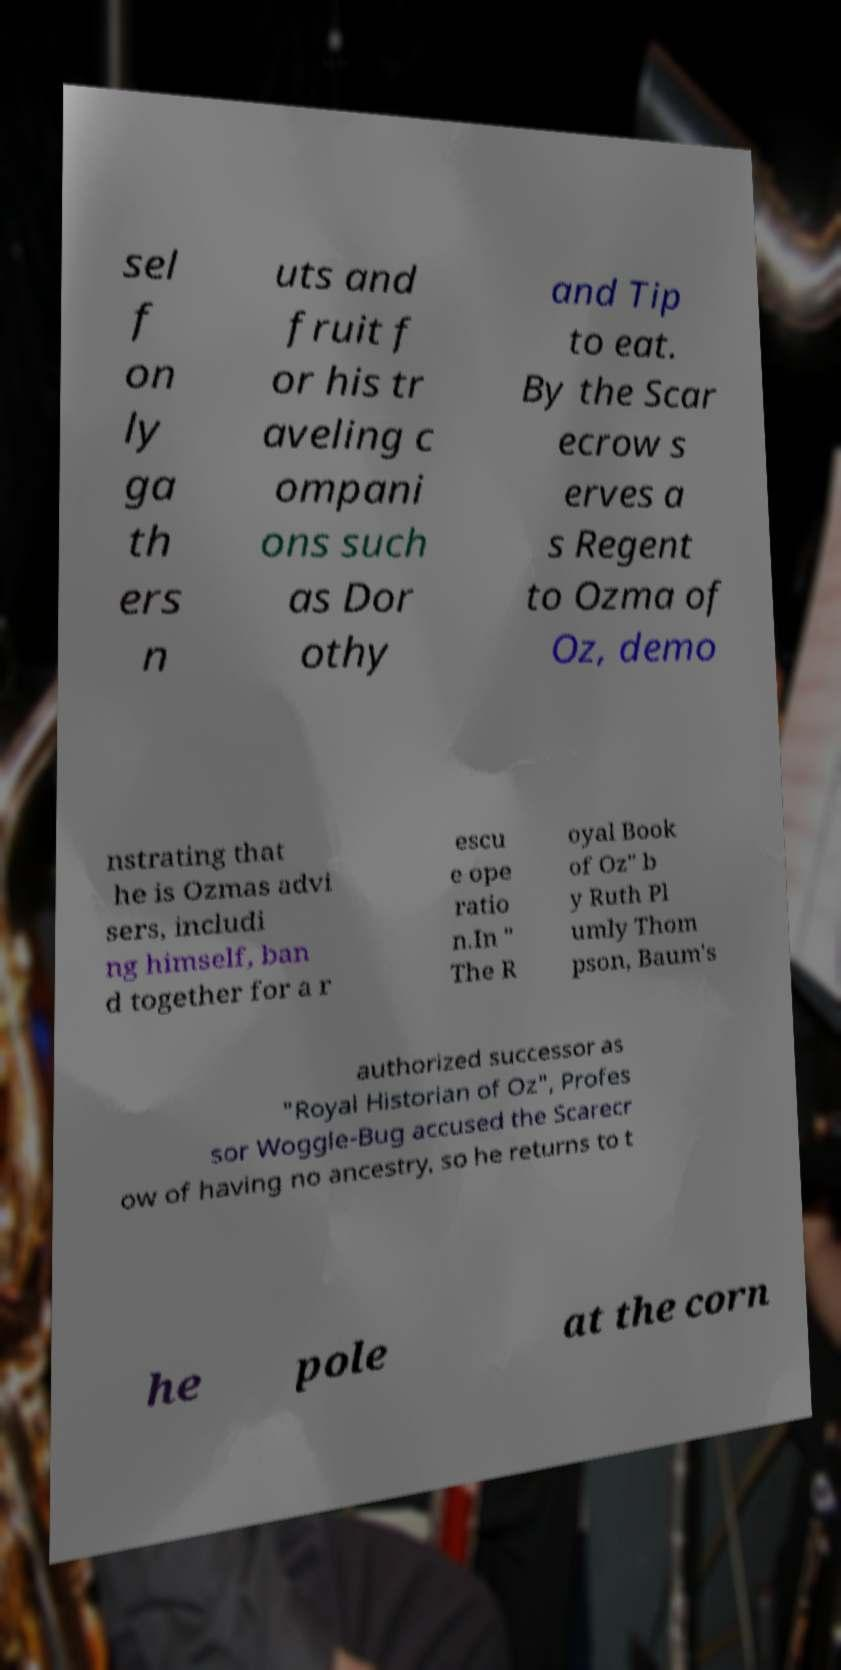Can you accurately transcribe the text from the provided image for me? sel f on ly ga th ers n uts and fruit f or his tr aveling c ompani ons such as Dor othy and Tip to eat. By the Scar ecrow s erves a s Regent to Ozma of Oz, demo nstrating that he is Ozmas advi sers, includi ng himself, ban d together for a r escu e ope ratio n.In " The R oyal Book of Oz" b y Ruth Pl umly Thom pson, Baum's authorized successor as "Royal Historian of Oz", Profes sor Woggle-Bug accused the Scarecr ow of having no ancestry, so he returns to t he pole at the corn 